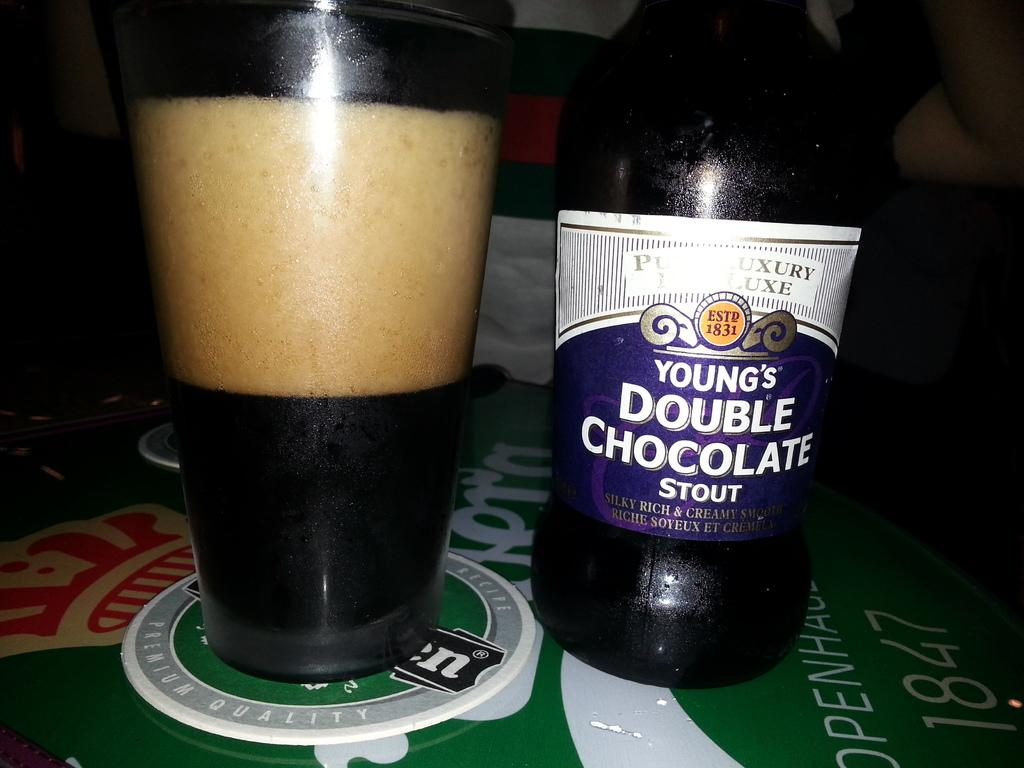<image>
Relay a brief, clear account of the picture shown. Young's Double Chocolate Stout is poured into a glass next to the bottle. 